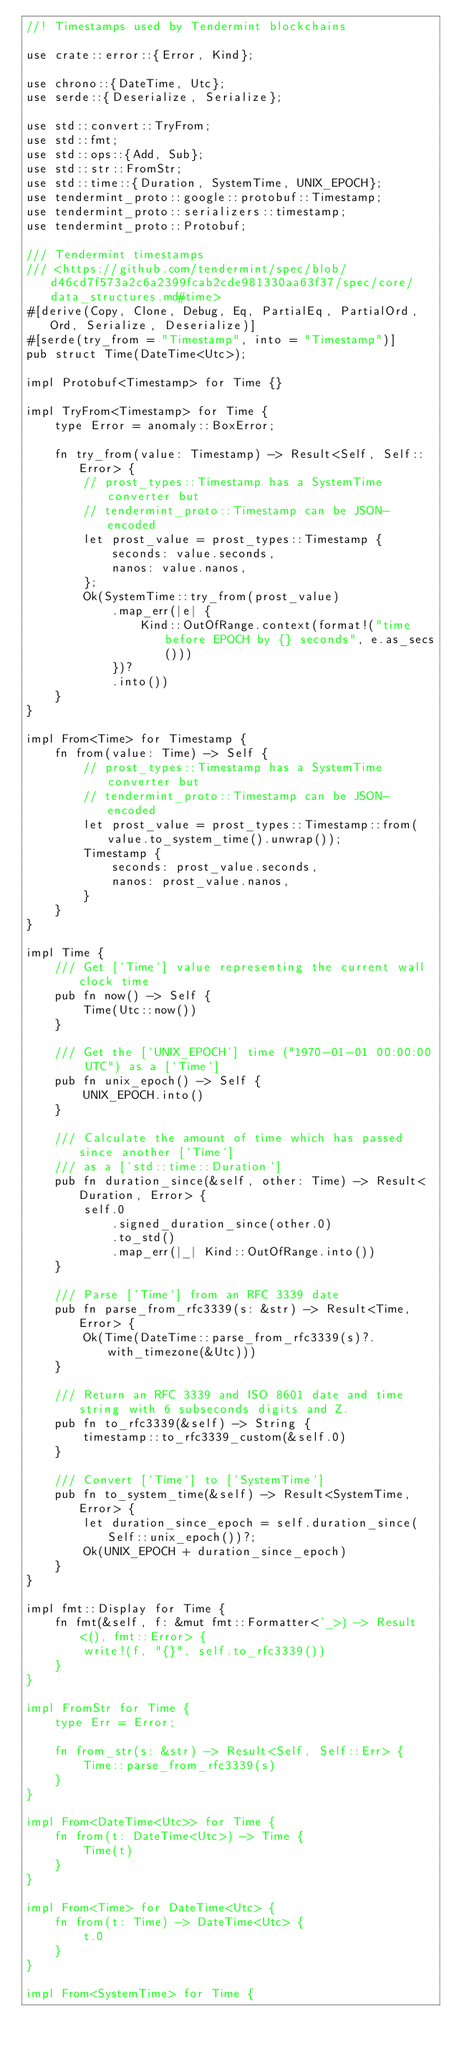Convert code to text. <code><loc_0><loc_0><loc_500><loc_500><_Rust_>//! Timestamps used by Tendermint blockchains

use crate::error::{Error, Kind};

use chrono::{DateTime, Utc};
use serde::{Deserialize, Serialize};

use std::convert::TryFrom;
use std::fmt;
use std::ops::{Add, Sub};
use std::str::FromStr;
use std::time::{Duration, SystemTime, UNIX_EPOCH};
use tendermint_proto::google::protobuf::Timestamp;
use tendermint_proto::serializers::timestamp;
use tendermint_proto::Protobuf;

/// Tendermint timestamps
/// <https://github.com/tendermint/spec/blob/d46cd7f573a2c6a2399fcab2cde981330aa63f37/spec/core/data_structures.md#time>
#[derive(Copy, Clone, Debug, Eq, PartialEq, PartialOrd, Ord, Serialize, Deserialize)]
#[serde(try_from = "Timestamp", into = "Timestamp")]
pub struct Time(DateTime<Utc>);

impl Protobuf<Timestamp> for Time {}

impl TryFrom<Timestamp> for Time {
    type Error = anomaly::BoxError;

    fn try_from(value: Timestamp) -> Result<Self, Self::Error> {
        // prost_types::Timestamp has a SystemTime converter but
        // tendermint_proto::Timestamp can be JSON-encoded
        let prost_value = prost_types::Timestamp {
            seconds: value.seconds,
            nanos: value.nanos,
        };
        Ok(SystemTime::try_from(prost_value)
            .map_err(|e| {
                Kind::OutOfRange.context(format!("time before EPOCH by {} seconds", e.as_secs()))
            })?
            .into())
    }
}

impl From<Time> for Timestamp {
    fn from(value: Time) -> Self {
        // prost_types::Timestamp has a SystemTime converter but
        // tendermint_proto::Timestamp can be JSON-encoded
        let prost_value = prost_types::Timestamp::from(value.to_system_time().unwrap());
        Timestamp {
            seconds: prost_value.seconds,
            nanos: prost_value.nanos,
        }
    }
}

impl Time {
    /// Get [`Time`] value representing the current wall clock time
    pub fn now() -> Self {
        Time(Utc::now())
    }

    /// Get the [`UNIX_EPOCH`] time ("1970-01-01 00:00:00 UTC") as a [`Time`]
    pub fn unix_epoch() -> Self {
        UNIX_EPOCH.into()
    }

    /// Calculate the amount of time which has passed since another [`Time`]
    /// as a [`std::time::Duration`]
    pub fn duration_since(&self, other: Time) -> Result<Duration, Error> {
        self.0
            .signed_duration_since(other.0)
            .to_std()
            .map_err(|_| Kind::OutOfRange.into())
    }

    /// Parse [`Time`] from an RFC 3339 date
    pub fn parse_from_rfc3339(s: &str) -> Result<Time, Error> {
        Ok(Time(DateTime::parse_from_rfc3339(s)?.with_timezone(&Utc)))
    }

    /// Return an RFC 3339 and ISO 8601 date and time string with 6 subseconds digits and Z.
    pub fn to_rfc3339(&self) -> String {
        timestamp::to_rfc3339_custom(&self.0)
    }

    /// Convert [`Time`] to [`SystemTime`]
    pub fn to_system_time(&self) -> Result<SystemTime, Error> {
        let duration_since_epoch = self.duration_since(Self::unix_epoch())?;
        Ok(UNIX_EPOCH + duration_since_epoch)
    }
}

impl fmt::Display for Time {
    fn fmt(&self, f: &mut fmt::Formatter<'_>) -> Result<(), fmt::Error> {
        write!(f, "{}", self.to_rfc3339())
    }
}

impl FromStr for Time {
    type Err = Error;

    fn from_str(s: &str) -> Result<Self, Self::Err> {
        Time::parse_from_rfc3339(s)
    }
}

impl From<DateTime<Utc>> for Time {
    fn from(t: DateTime<Utc>) -> Time {
        Time(t)
    }
}

impl From<Time> for DateTime<Utc> {
    fn from(t: Time) -> DateTime<Utc> {
        t.0
    }
}

impl From<SystemTime> for Time {</code> 